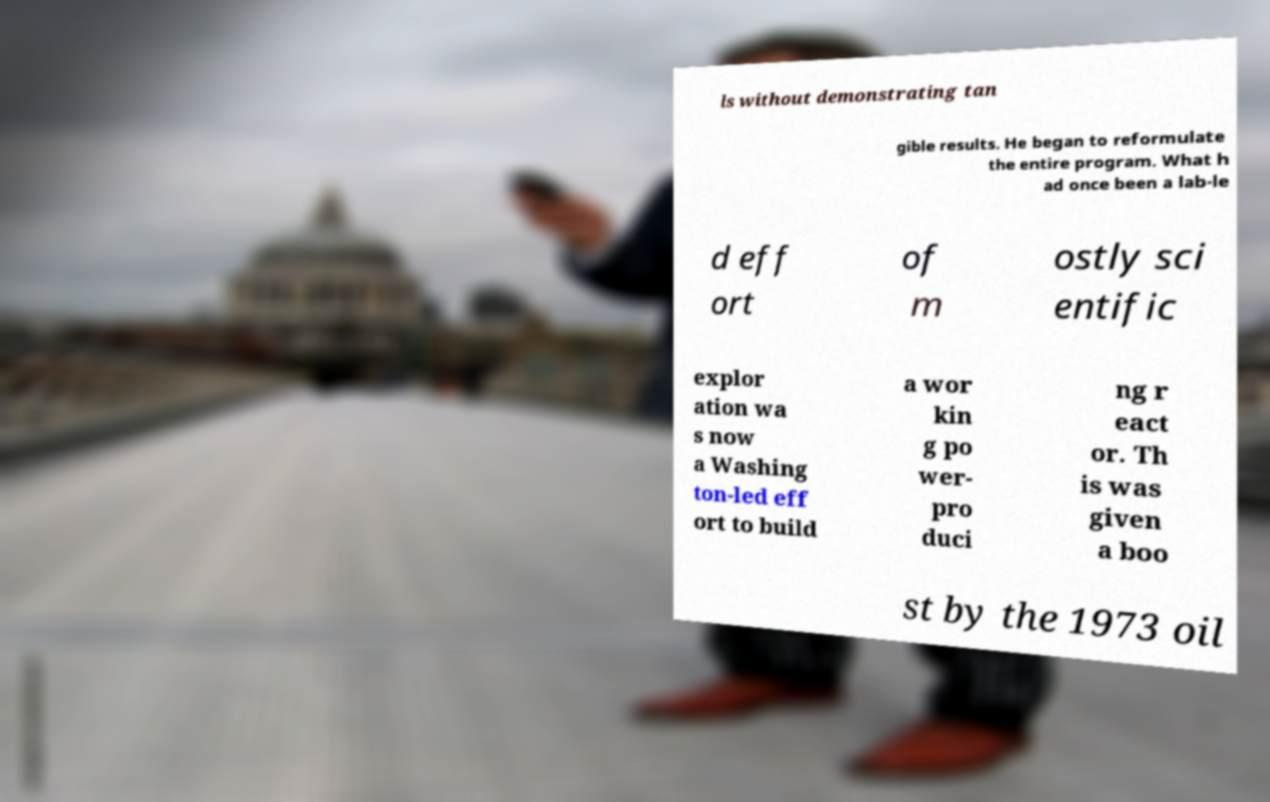What messages or text are displayed in this image? I need them in a readable, typed format. ls without demonstrating tan gible results. He began to reformulate the entire program. What h ad once been a lab-le d eff ort of m ostly sci entific explor ation wa s now a Washing ton-led eff ort to build a wor kin g po wer- pro duci ng r eact or. Th is was given a boo st by the 1973 oil 